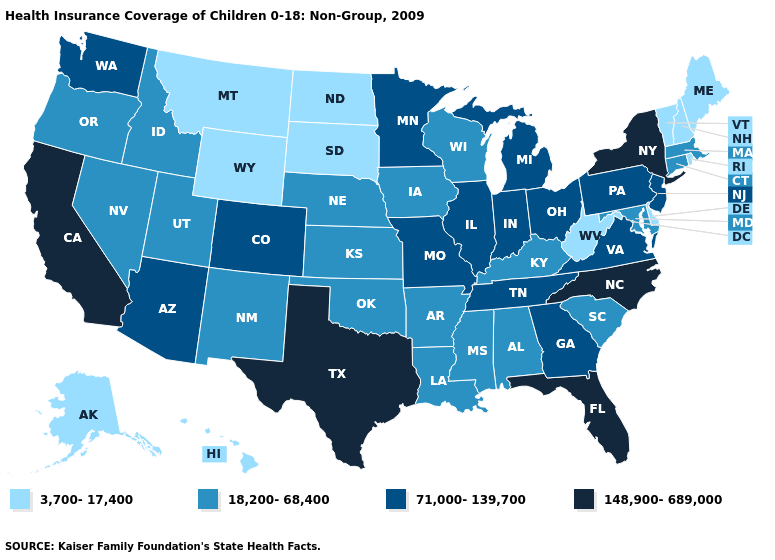Does Utah have the lowest value in the West?
Be succinct. No. Is the legend a continuous bar?
Write a very short answer. No. What is the lowest value in the MidWest?
Be succinct. 3,700-17,400. Does Florida have the lowest value in the USA?
Concise answer only. No. What is the highest value in the South ?
Quick response, please. 148,900-689,000. What is the value of Florida?
Concise answer only. 148,900-689,000. What is the lowest value in the West?
Short answer required. 3,700-17,400. Name the states that have a value in the range 71,000-139,700?
Answer briefly. Arizona, Colorado, Georgia, Illinois, Indiana, Michigan, Minnesota, Missouri, New Jersey, Ohio, Pennsylvania, Tennessee, Virginia, Washington. What is the value of Mississippi?
Concise answer only. 18,200-68,400. Name the states that have a value in the range 18,200-68,400?
Quick response, please. Alabama, Arkansas, Connecticut, Idaho, Iowa, Kansas, Kentucky, Louisiana, Maryland, Massachusetts, Mississippi, Nebraska, Nevada, New Mexico, Oklahoma, Oregon, South Carolina, Utah, Wisconsin. Does New Mexico have the lowest value in the West?
Answer briefly. No. Which states hav the highest value in the Northeast?
Write a very short answer. New York. What is the value of Arkansas?
Give a very brief answer. 18,200-68,400. Name the states that have a value in the range 18,200-68,400?
Short answer required. Alabama, Arkansas, Connecticut, Idaho, Iowa, Kansas, Kentucky, Louisiana, Maryland, Massachusetts, Mississippi, Nebraska, Nevada, New Mexico, Oklahoma, Oregon, South Carolina, Utah, Wisconsin. Does Arizona have a lower value than New York?
Be succinct. Yes. 